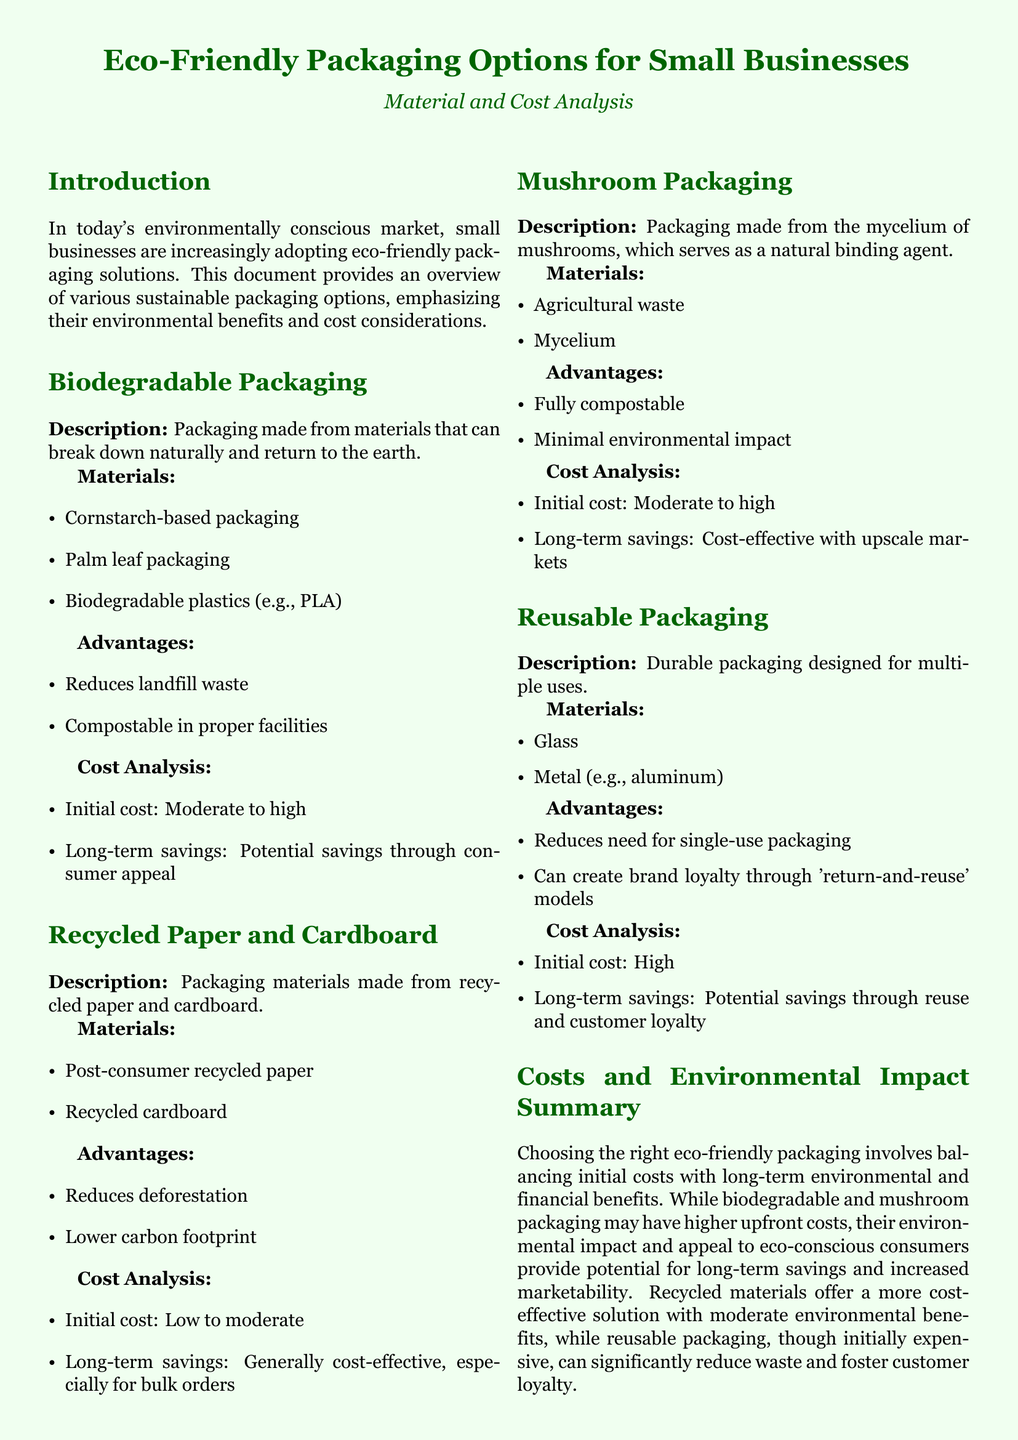What are three materials used in biodegradable packaging? The document lists cornstarch-based packaging, palm leaf packaging, and biodegradable plastics as materials for biodegradable packaging.
Answer: Cornstarch-based packaging, palm leaf packaging, biodegradable plastics What is the initial cost range for recycled paper and cardboard? The document states that the initial cost for recycled paper and cardboard is low to moderate.
Answer: Low to moderate What is one advantage of mushroom packaging? One advantage highlighted in the document is that mushroom packaging is fully compostable.
Answer: Fully compostable What long-term benefit is associated with reusable packaging? The document mentions potential savings through reuse and customer loyalty as a long-term benefit of reusable packaging.
Answer: Reuse and customer loyalty What overall potential does eco-friendly packaging have for small businesses? The document indicates that eco-friendly packaging can attract a growing base of eco-conscious consumers.
Answer: Attract eco-conscious consumers What is the potential initial cost of biodegradable packaging? The document specifies that the initial cost of biodegradable packaging is moderate to high.
Answer: Moderate to high 